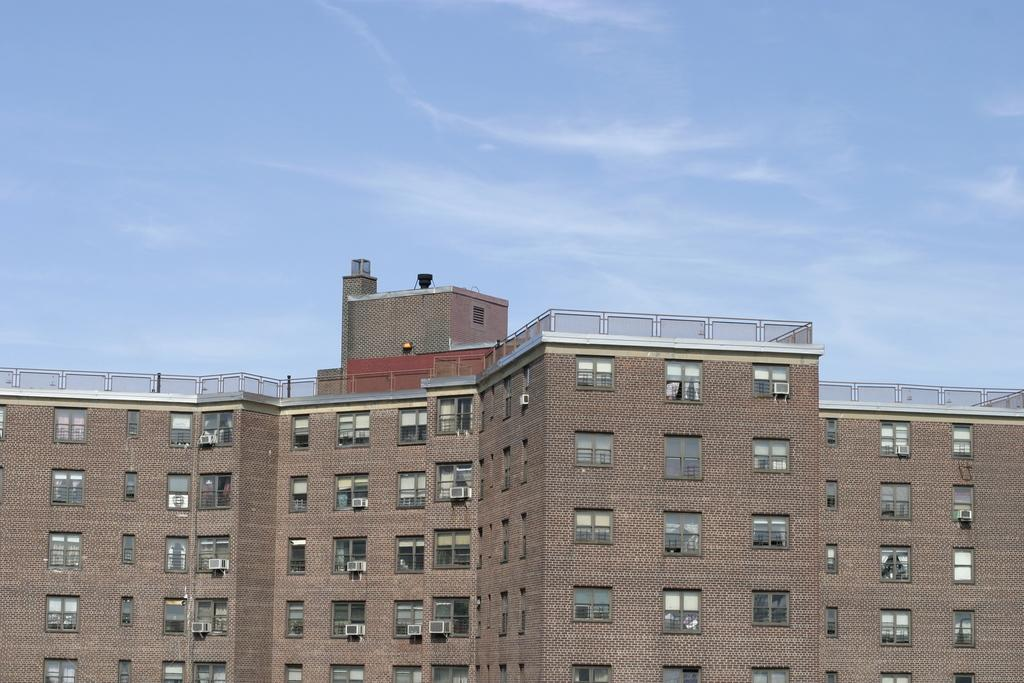What is the main subject of the picture? The main subject of the picture is a huge building. What specific features can be observed on the building? The building has windows and is multi-storied. What is the condition of the sky in the picture? The sky is clear in the picture. What type of action is taking place in the picture involving a calendar? There is no action or calendar present in the image; it only features a huge building with windows and a clear sky. 